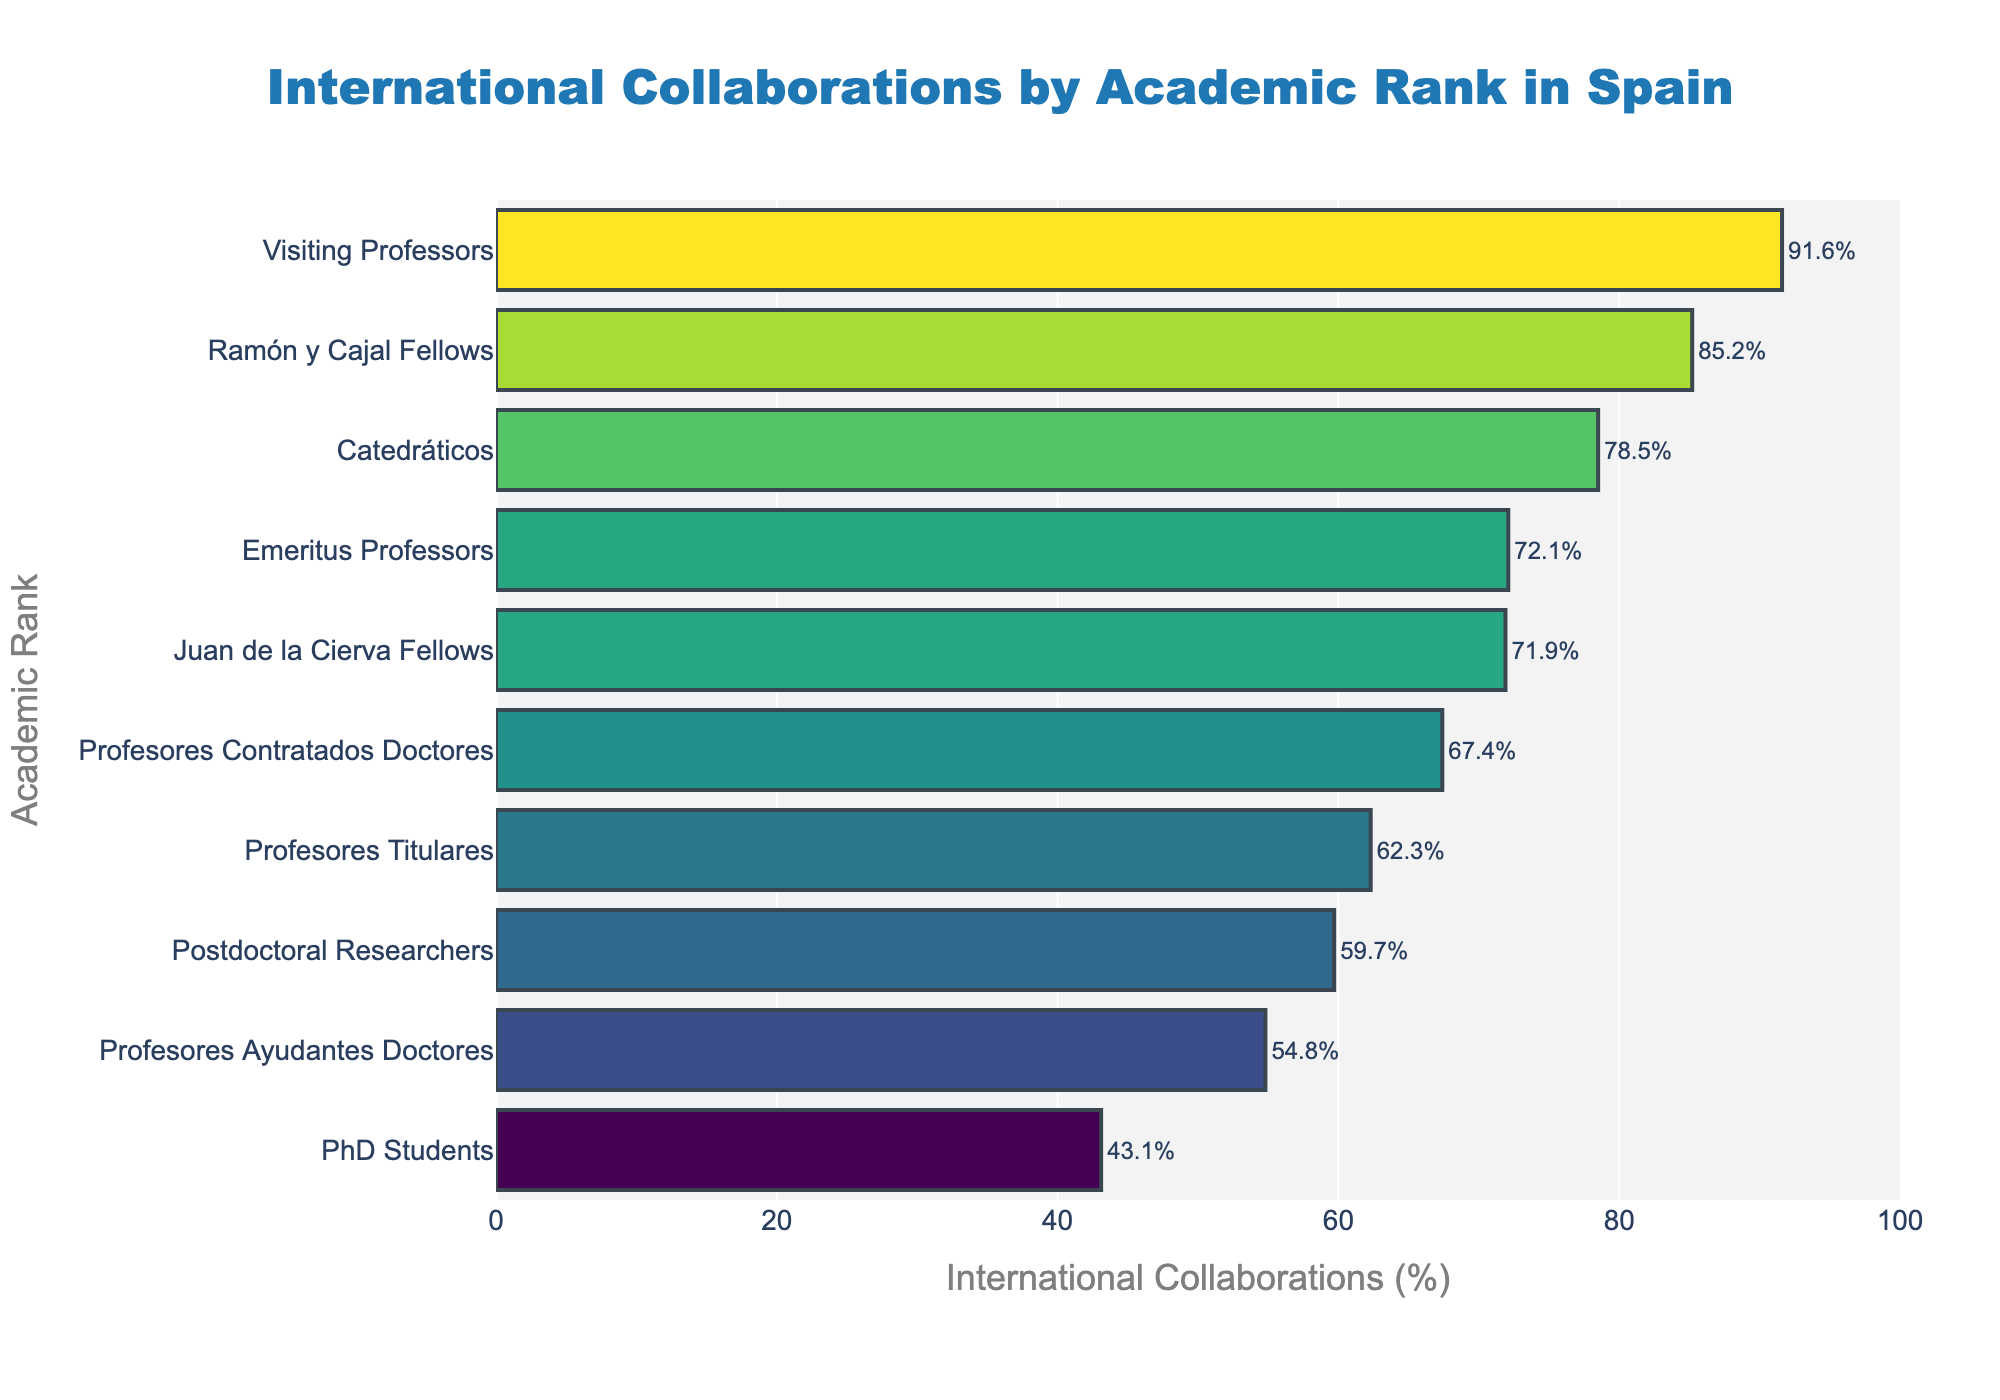Which academic rank has the highest percentage of international collaborations? The plot displays the percentage of international collaborations for each academic rank. The highest value for international collaborations is associated with Visiting Professors, as their bar extends the furthest to the right
Answer: Visiting Professors Compare the international collaborations between Ramón y Cajal Fellows and Juan de la Cierva Fellows According to the chart, Ramón y Cajal Fellows have a higher percentage (85.2%) of international collaborations compared to Juan de la Cierva Fellows (71.9%)
Answer: Ramón y Cajal Fellows have a higher percentage What is the difference in international collaborations between Catedráticos and PhD Students? Catedráticos have a 78.5% international collaboration rate, while PhD Students have 43.1%. The difference is calculated by subtracting the smaller percentage from the larger one: 78.5% - 43.1% = 35.4%
Answer: 35.4% Which two academic ranks have the closest percentage of international collaborations? Comparing the differences between adjacent bars in the sorted graph, Emeritus Professors (72.1%) and Juan de la Cierva Fellows (71.9%) have the closest percentages
Answer: Emeritus Professors and Juan de la Cierva Fellows What is the average percentage of international collaborations for the top three academic ranks? The top three ranks based on the percentage are Visiting Professors (91.6%), Ramón y Cajal Fellows (85.2%), and Catedráticos (78.5%). The average is calculated as (91.6 + 85.2 + 78.5) / 3 = 85.1%
Answer: 85.1% Which academic rank has a percentage of international collaborations closest to 60%? From the chart, Profesores Titulares have a 62.3% collaboration rate, and Postdoctoral Researchers have 59.7%. Postdoctoral Researchers are closer to 60%
Answer: Postdoctoral Researchers What is the combined percentage of international collaborations for Professores Contratados Doctores and Profesores Titulares? Summing their percentages: Profesores Contratados Doctores (67.4%) + Profesores Titulares (62.3%) = 129.7%
Answer: 129.7% Identify the academic rank with the lowest percentage of international collaborations The smallest bar, indicating the lowest percentage, belongs to PhD Students with 43.1%
Answer: PhD Students 